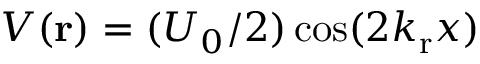Convert formula to latex. <formula><loc_0><loc_0><loc_500><loc_500>V ( { r } ) = ( U _ { 0 } / 2 ) \cos ( 2 k _ { \mathrm r } x )</formula> 